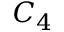<formula> <loc_0><loc_0><loc_500><loc_500>C _ { 4 }</formula> 